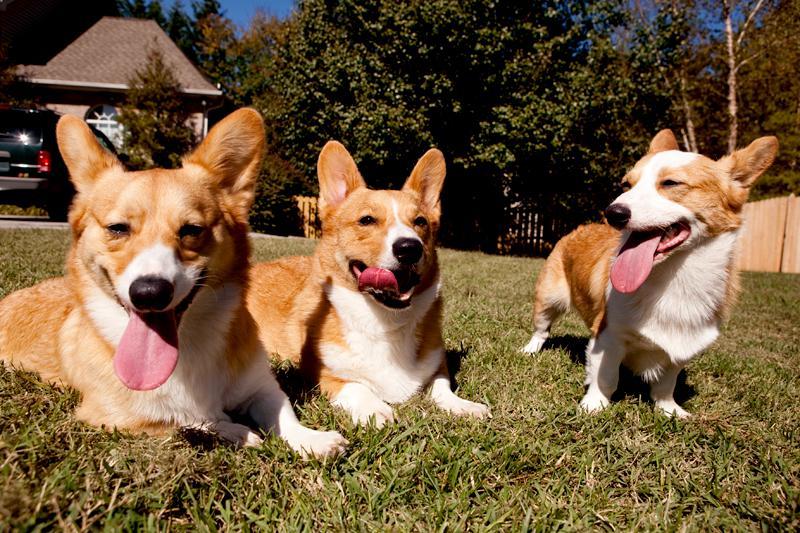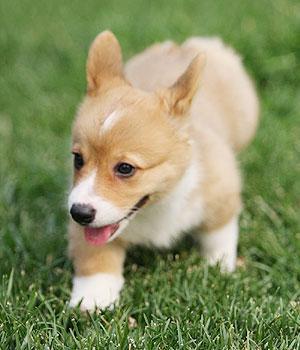The first image is the image on the left, the second image is the image on the right. Considering the images on both sides, is "An image shows exactly one short-legged dog, which is standing in the grass." valid? Answer yes or no. Yes. The first image is the image on the left, the second image is the image on the right. Given the left and right images, does the statement "At least one dog has its tongue sticking out of its mouth." hold true? Answer yes or no. Yes. 